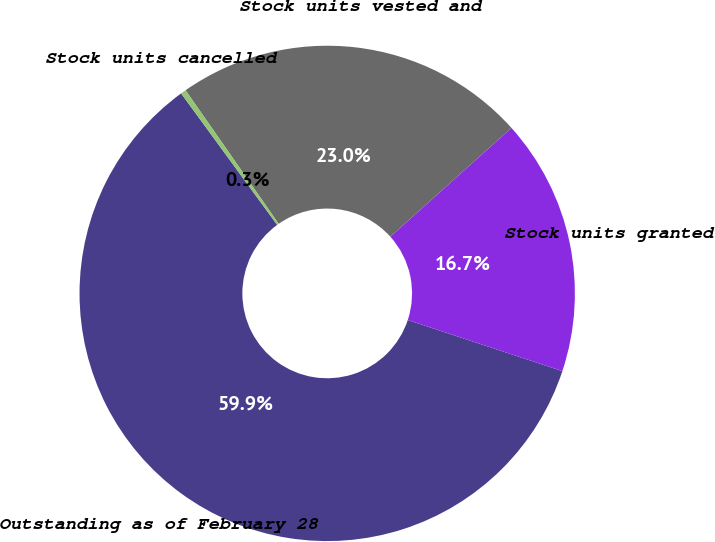Convert chart. <chart><loc_0><loc_0><loc_500><loc_500><pie_chart><fcel>Outstanding as of February 28<fcel>Stock units granted<fcel>Stock units vested and<fcel>Stock units cancelled<nl><fcel>59.88%<fcel>16.73%<fcel>23.04%<fcel>0.35%<nl></chart> 